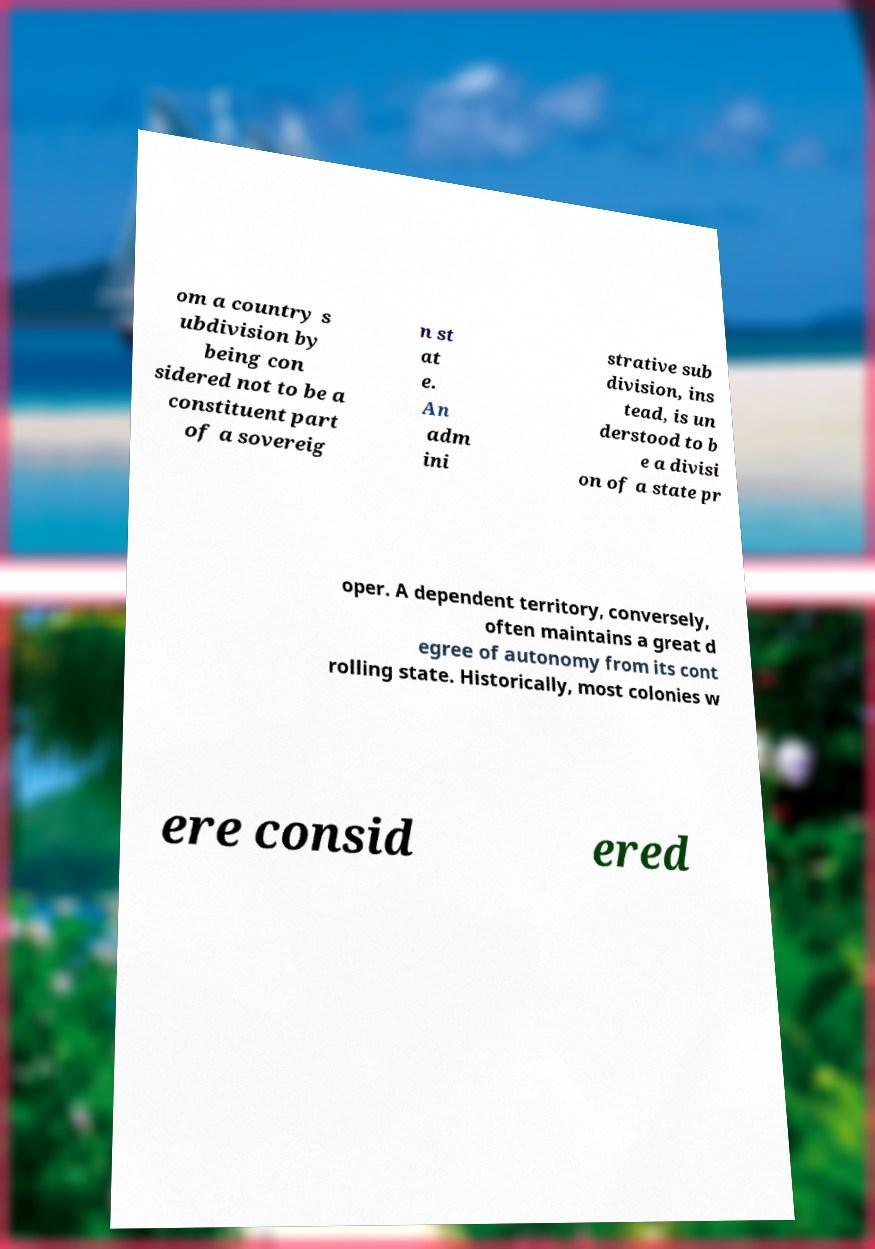Please read and relay the text visible in this image. What does it say? om a country s ubdivision by being con sidered not to be a constituent part of a sovereig n st at e. An adm ini strative sub division, ins tead, is un derstood to b e a divisi on of a state pr oper. A dependent territory, conversely, often maintains a great d egree of autonomy from its cont rolling state. Historically, most colonies w ere consid ered 